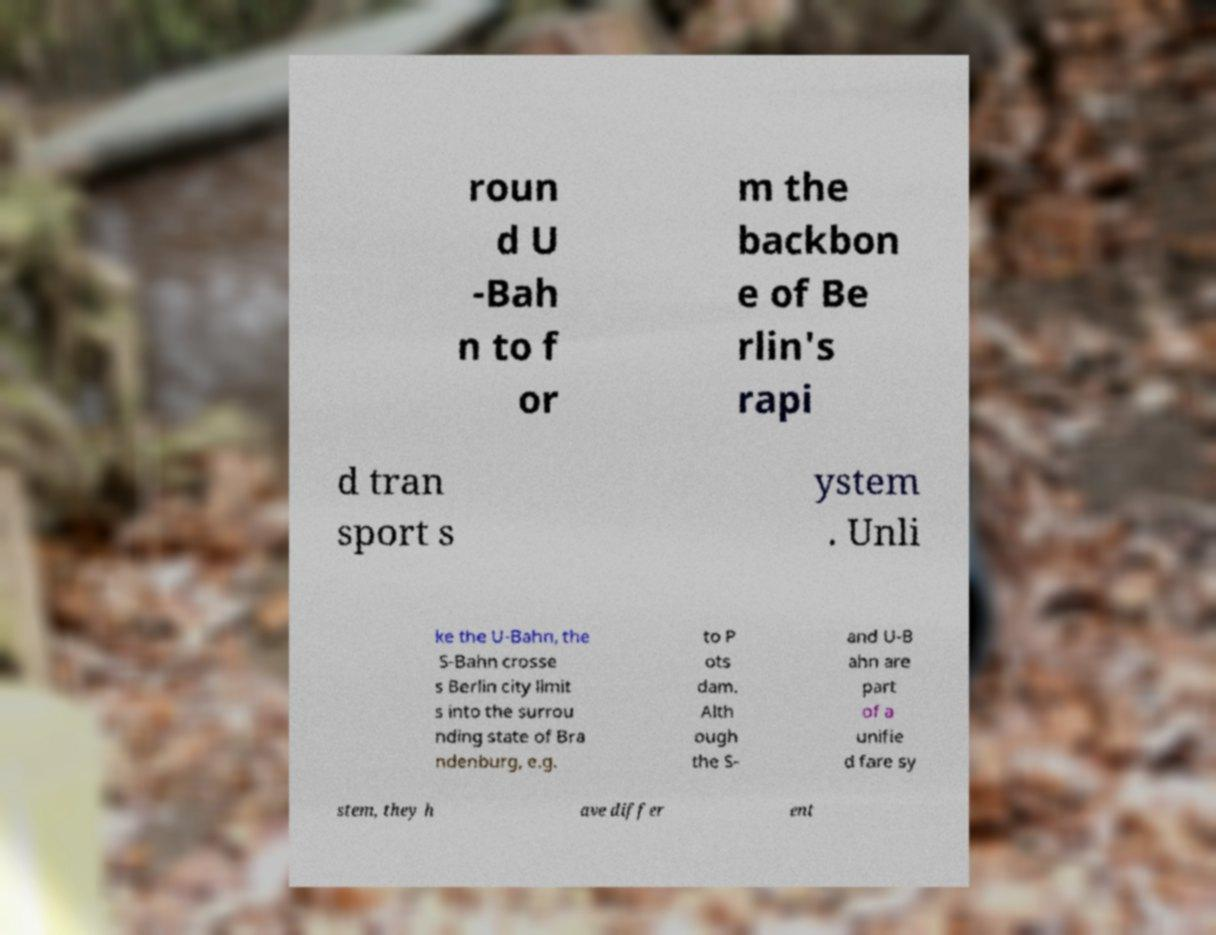Please identify and transcribe the text found in this image. roun d U -Bah n to f or m the backbon e of Be rlin's rapi d tran sport s ystem . Unli ke the U-Bahn, the S-Bahn crosse s Berlin city limit s into the surrou nding state of Bra ndenburg, e.g. to P ots dam. Alth ough the S- and U-B ahn are part of a unifie d fare sy stem, they h ave differ ent 